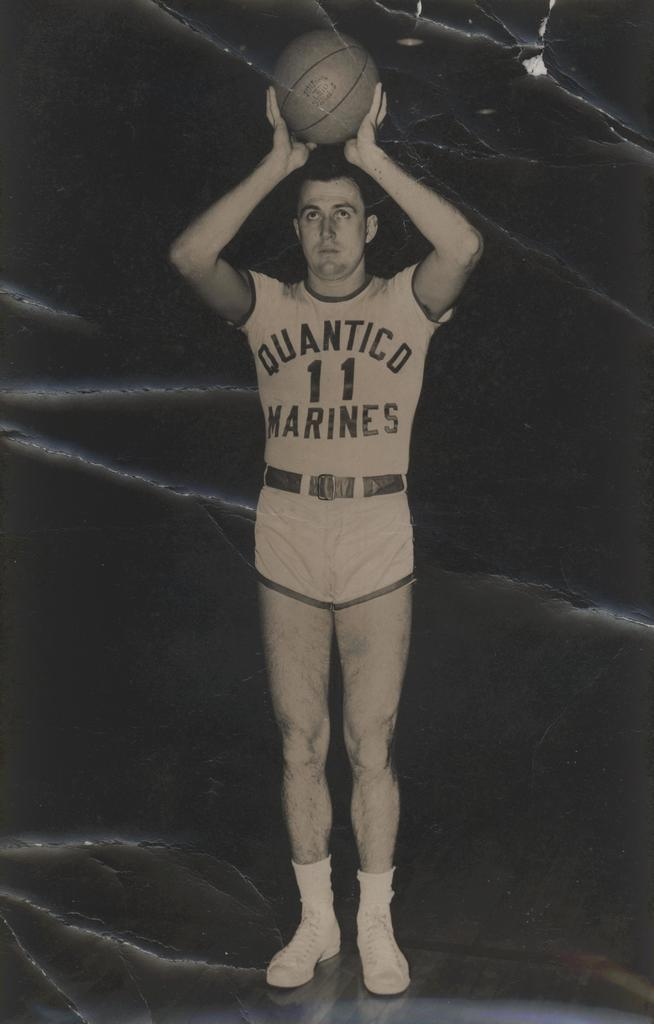<image>
Give a short and clear explanation of the subsequent image. a man with a basketball that has the word marines on it 